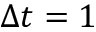<formula> <loc_0><loc_0><loc_500><loc_500>\Delta t = 1</formula> 